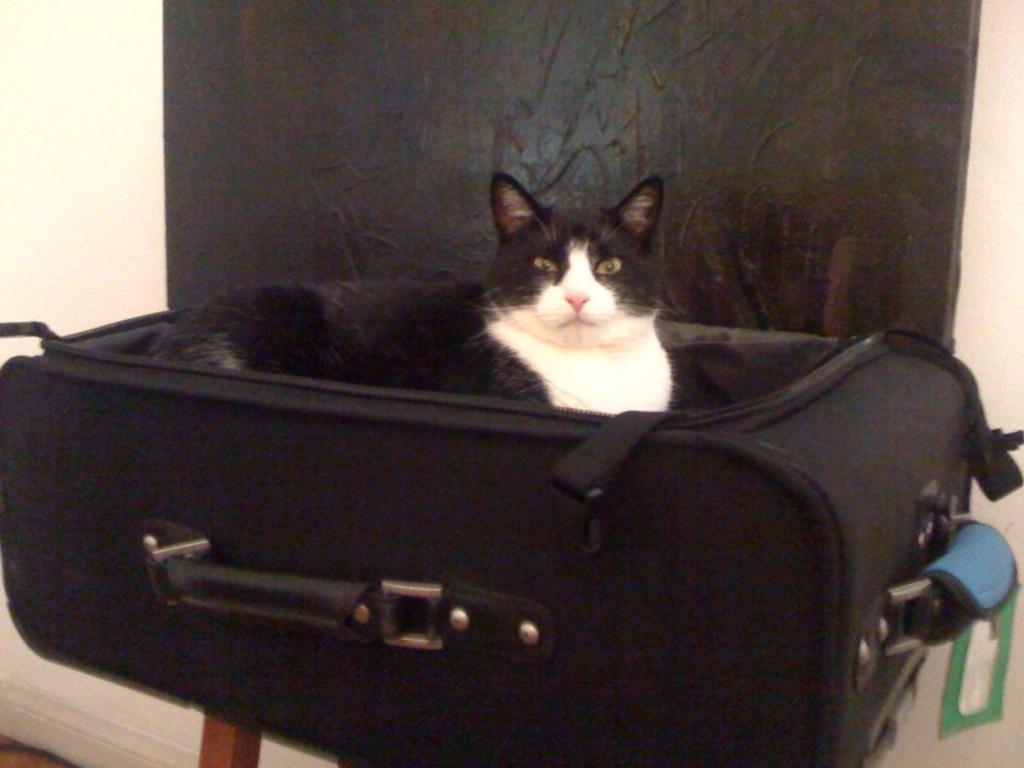Describe this image in one or two sentences. There is a cat in the luggage trolley placed on a table. In the background there is a wall. 